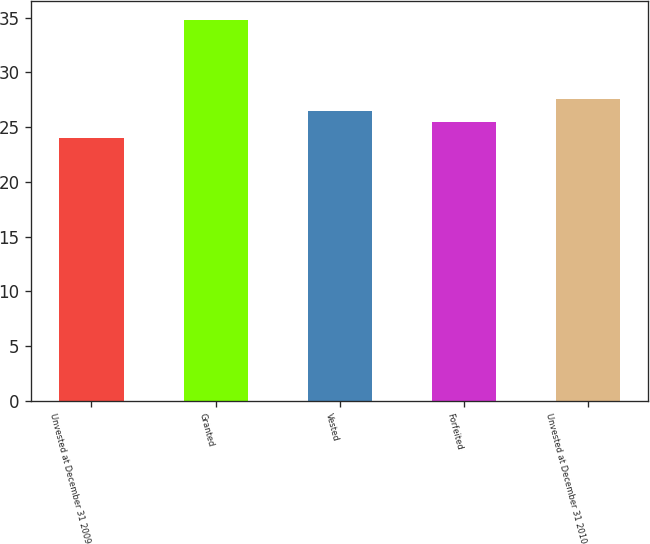Convert chart to OTSL. <chart><loc_0><loc_0><loc_500><loc_500><bar_chart><fcel>Unvested at December 31 2009<fcel>Granted<fcel>Vested<fcel>Forfeited<fcel>Unvested at December 31 2010<nl><fcel>24.04<fcel>34.73<fcel>26.51<fcel>25.44<fcel>27.58<nl></chart> 